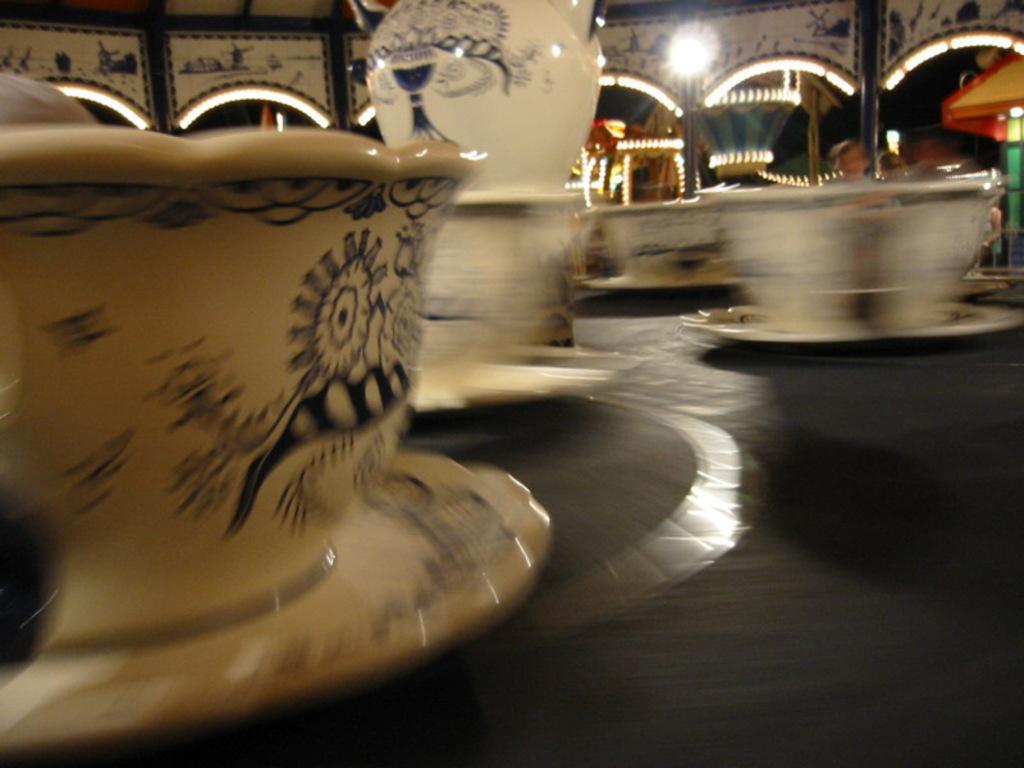In one or two sentences, can you explain what this image depicts? In this image there is a table on that table there are cups and saucer and a mug, in the background there is an entrance and lighting. 